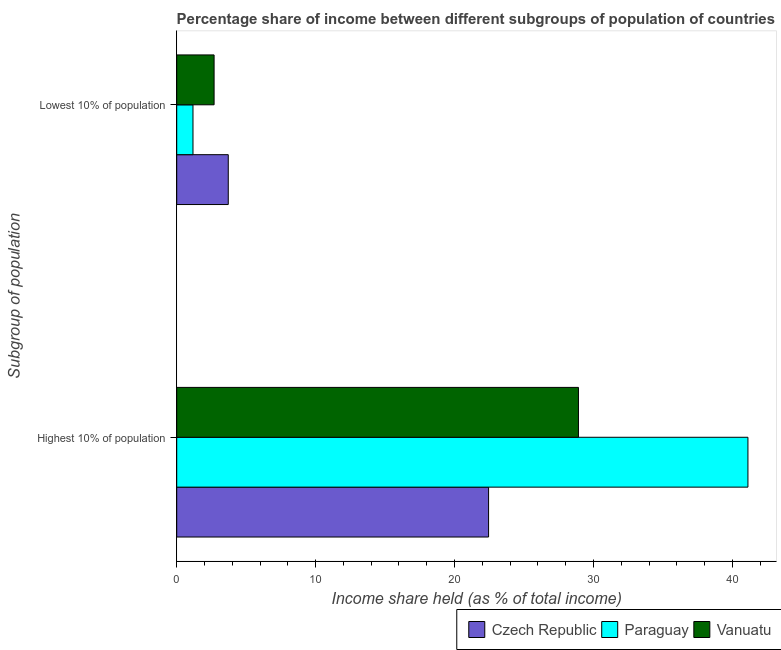How many different coloured bars are there?
Make the answer very short. 3. How many bars are there on the 2nd tick from the bottom?
Provide a succinct answer. 3. What is the label of the 1st group of bars from the top?
Make the answer very short. Lowest 10% of population. What is the income share held by lowest 10% of the population in Czech Republic?
Your answer should be compact. 3.71. Across all countries, what is the maximum income share held by lowest 10% of the population?
Provide a short and direct response. 3.71. Across all countries, what is the minimum income share held by lowest 10% of the population?
Give a very brief answer. 1.17. In which country was the income share held by lowest 10% of the population maximum?
Provide a short and direct response. Czech Republic. In which country was the income share held by lowest 10% of the population minimum?
Provide a short and direct response. Paraguay. What is the total income share held by highest 10% of the population in the graph?
Provide a short and direct response. 92.49. What is the difference between the income share held by highest 10% of the population in Paraguay and the income share held by lowest 10% of the population in Czech Republic?
Offer a terse response. 37.41. What is the average income share held by highest 10% of the population per country?
Provide a succinct answer. 30.83. What is the difference between the income share held by highest 10% of the population and income share held by lowest 10% of the population in Paraguay?
Keep it short and to the point. 39.95. What is the ratio of the income share held by lowest 10% of the population in Vanuatu to that in Czech Republic?
Keep it short and to the point. 0.73. Is the income share held by lowest 10% of the population in Vanuatu less than that in Czech Republic?
Provide a succinct answer. Yes. In how many countries, is the income share held by lowest 10% of the population greater than the average income share held by lowest 10% of the population taken over all countries?
Provide a succinct answer. 2. What does the 2nd bar from the top in Lowest 10% of population represents?
Your answer should be very brief. Paraguay. What does the 2nd bar from the bottom in Highest 10% of population represents?
Your answer should be compact. Paraguay. How many bars are there?
Offer a terse response. 6. Are all the bars in the graph horizontal?
Give a very brief answer. Yes. Are the values on the major ticks of X-axis written in scientific E-notation?
Provide a short and direct response. No. Does the graph contain any zero values?
Provide a short and direct response. No. Does the graph contain grids?
Your answer should be very brief. No. How many legend labels are there?
Your answer should be very brief. 3. What is the title of the graph?
Offer a very short reply. Percentage share of income between different subgroups of population of countries. Does "Sao Tome and Principe" appear as one of the legend labels in the graph?
Your answer should be compact. No. What is the label or title of the X-axis?
Offer a very short reply. Income share held (as % of total income). What is the label or title of the Y-axis?
Offer a very short reply. Subgroup of population. What is the Income share held (as % of total income) in Czech Republic in Highest 10% of population?
Your response must be concise. 22.45. What is the Income share held (as % of total income) of Paraguay in Highest 10% of population?
Provide a succinct answer. 41.12. What is the Income share held (as % of total income) in Vanuatu in Highest 10% of population?
Make the answer very short. 28.92. What is the Income share held (as % of total income) in Czech Republic in Lowest 10% of population?
Your response must be concise. 3.71. What is the Income share held (as % of total income) of Paraguay in Lowest 10% of population?
Give a very brief answer. 1.17. What is the Income share held (as % of total income) of Vanuatu in Lowest 10% of population?
Your response must be concise. 2.69. Across all Subgroup of population, what is the maximum Income share held (as % of total income) in Czech Republic?
Your answer should be compact. 22.45. Across all Subgroup of population, what is the maximum Income share held (as % of total income) of Paraguay?
Offer a terse response. 41.12. Across all Subgroup of population, what is the maximum Income share held (as % of total income) in Vanuatu?
Ensure brevity in your answer.  28.92. Across all Subgroup of population, what is the minimum Income share held (as % of total income) of Czech Republic?
Give a very brief answer. 3.71. Across all Subgroup of population, what is the minimum Income share held (as % of total income) of Paraguay?
Your answer should be compact. 1.17. Across all Subgroup of population, what is the minimum Income share held (as % of total income) in Vanuatu?
Offer a terse response. 2.69. What is the total Income share held (as % of total income) in Czech Republic in the graph?
Offer a very short reply. 26.16. What is the total Income share held (as % of total income) in Paraguay in the graph?
Keep it short and to the point. 42.29. What is the total Income share held (as % of total income) of Vanuatu in the graph?
Your answer should be very brief. 31.61. What is the difference between the Income share held (as % of total income) of Czech Republic in Highest 10% of population and that in Lowest 10% of population?
Your response must be concise. 18.74. What is the difference between the Income share held (as % of total income) of Paraguay in Highest 10% of population and that in Lowest 10% of population?
Ensure brevity in your answer.  39.95. What is the difference between the Income share held (as % of total income) of Vanuatu in Highest 10% of population and that in Lowest 10% of population?
Make the answer very short. 26.23. What is the difference between the Income share held (as % of total income) in Czech Republic in Highest 10% of population and the Income share held (as % of total income) in Paraguay in Lowest 10% of population?
Offer a terse response. 21.28. What is the difference between the Income share held (as % of total income) of Czech Republic in Highest 10% of population and the Income share held (as % of total income) of Vanuatu in Lowest 10% of population?
Offer a terse response. 19.76. What is the difference between the Income share held (as % of total income) in Paraguay in Highest 10% of population and the Income share held (as % of total income) in Vanuatu in Lowest 10% of population?
Offer a very short reply. 38.43. What is the average Income share held (as % of total income) of Czech Republic per Subgroup of population?
Your answer should be very brief. 13.08. What is the average Income share held (as % of total income) of Paraguay per Subgroup of population?
Your response must be concise. 21.14. What is the average Income share held (as % of total income) in Vanuatu per Subgroup of population?
Offer a very short reply. 15.8. What is the difference between the Income share held (as % of total income) of Czech Republic and Income share held (as % of total income) of Paraguay in Highest 10% of population?
Provide a succinct answer. -18.67. What is the difference between the Income share held (as % of total income) of Czech Republic and Income share held (as % of total income) of Vanuatu in Highest 10% of population?
Your answer should be compact. -6.47. What is the difference between the Income share held (as % of total income) of Paraguay and Income share held (as % of total income) of Vanuatu in Highest 10% of population?
Your response must be concise. 12.2. What is the difference between the Income share held (as % of total income) in Czech Republic and Income share held (as % of total income) in Paraguay in Lowest 10% of population?
Offer a terse response. 2.54. What is the difference between the Income share held (as % of total income) in Paraguay and Income share held (as % of total income) in Vanuatu in Lowest 10% of population?
Provide a short and direct response. -1.52. What is the ratio of the Income share held (as % of total income) of Czech Republic in Highest 10% of population to that in Lowest 10% of population?
Offer a terse response. 6.05. What is the ratio of the Income share held (as % of total income) of Paraguay in Highest 10% of population to that in Lowest 10% of population?
Your answer should be compact. 35.15. What is the ratio of the Income share held (as % of total income) of Vanuatu in Highest 10% of population to that in Lowest 10% of population?
Offer a very short reply. 10.75. What is the difference between the highest and the second highest Income share held (as % of total income) in Czech Republic?
Offer a terse response. 18.74. What is the difference between the highest and the second highest Income share held (as % of total income) in Paraguay?
Provide a short and direct response. 39.95. What is the difference between the highest and the second highest Income share held (as % of total income) in Vanuatu?
Your response must be concise. 26.23. What is the difference between the highest and the lowest Income share held (as % of total income) of Czech Republic?
Give a very brief answer. 18.74. What is the difference between the highest and the lowest Income share held (as % of total income) in Paraguay?
Keep it short and to the point. 39.95. What is the difference between the highest and the lowest Income share held (as % of total income) in Vanuatu?
Provide a short and direct response. 26.23. 